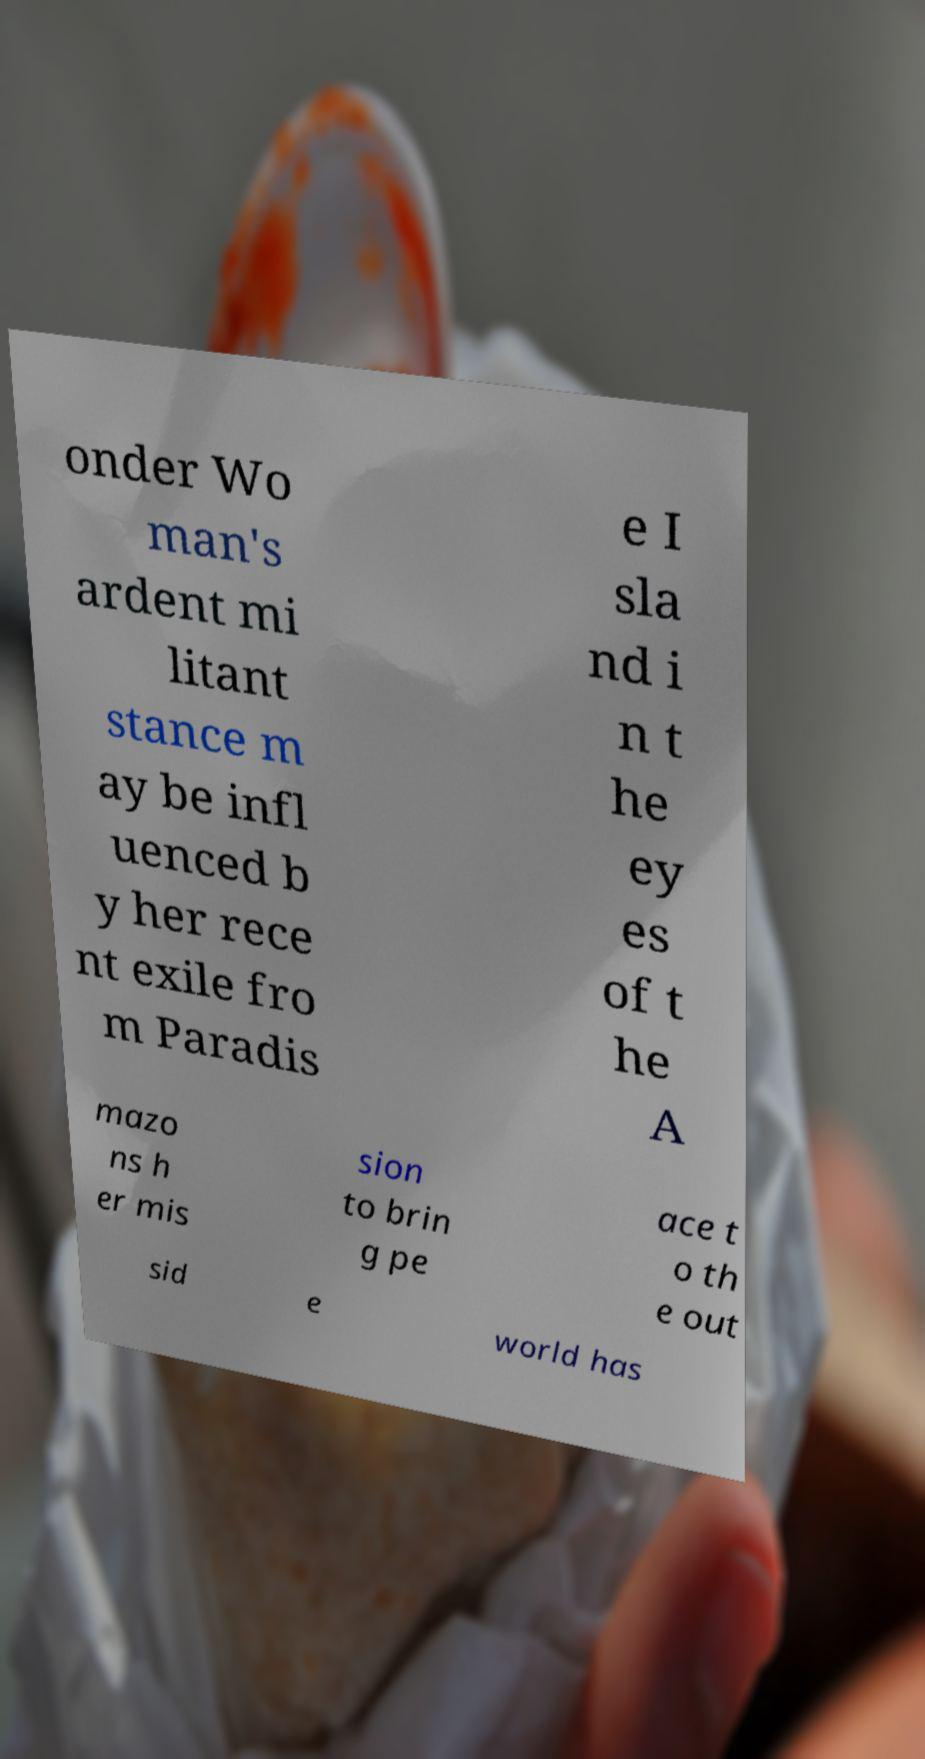Could you assist in decoding the text presented in this image and type it out clearly? onder Wo man's ardent mi litant stance m ay be infl uenced b y her rece nt exile fro m Paradis e I sla nd i n t he ey es of t he A mazo ns h er mis sion to brin g pe ace t o th e out sid e world has 